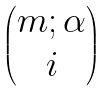Convert formula to latex. <formula><loc_0><loc_0><loc_500><loc_500>\begin{pmatrix} m ; \alpha \\ i \\ \end{pmatrix}</formula> 